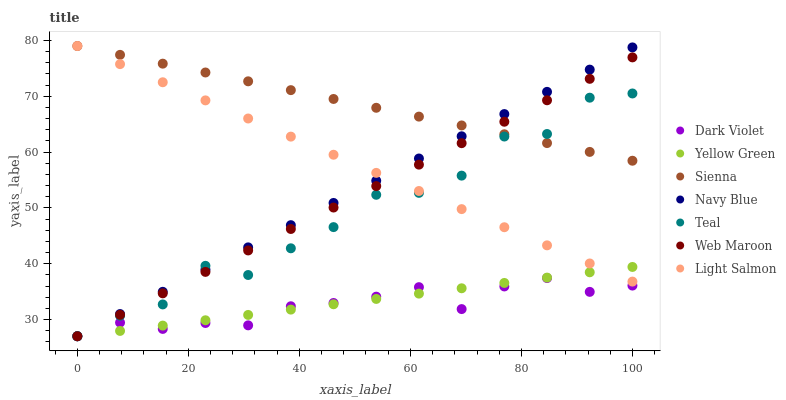Does Dark Violet have the minimum area under the curve?
Answer yes or no. Yes. Does Sienna have the maximum area under the curve?
Answer yes or no. Yes. Does Yellow Green have the minimum area under the curve?
Answer yes or no. No. Does Yellow Green have the maximum area under the curve?
Answer yes or no. No. Is Yellow Green the smoothest?
Answer yes or no. Yes. Is Teal the roughest?
Answer yes or no. Yes. Is Navy Blue the smoothest?
Answer yes or no. No. Is Navy Blue the roughest?
Answer yes or no. No. Does Yellow Green have the lowest value?
Answer yes or no. Yes. Does Sienna have the lowest value?
Answer yes or no. No. Does Sienna have the highest value?
Answer yes or no. Yes. Does Yellow Green have the highest value?
Answer yes or no. No. Is Dark Violet less than Light Salmon?
Answer yes or no. Yes. Is Sienna greater than Yellow Green?
Answer yes or no. Yes. Does Navy Blue intersect Yellow Green?
Answer yes or no. Yes. Is Navy Blue less than Yellow Green?
Answer yes or no. No. Is Navy Blue greater than Yellow Green?
Answer yes or no. No. Does Dark Violet intersect Light Salmon?
Answer yes or no. No. 